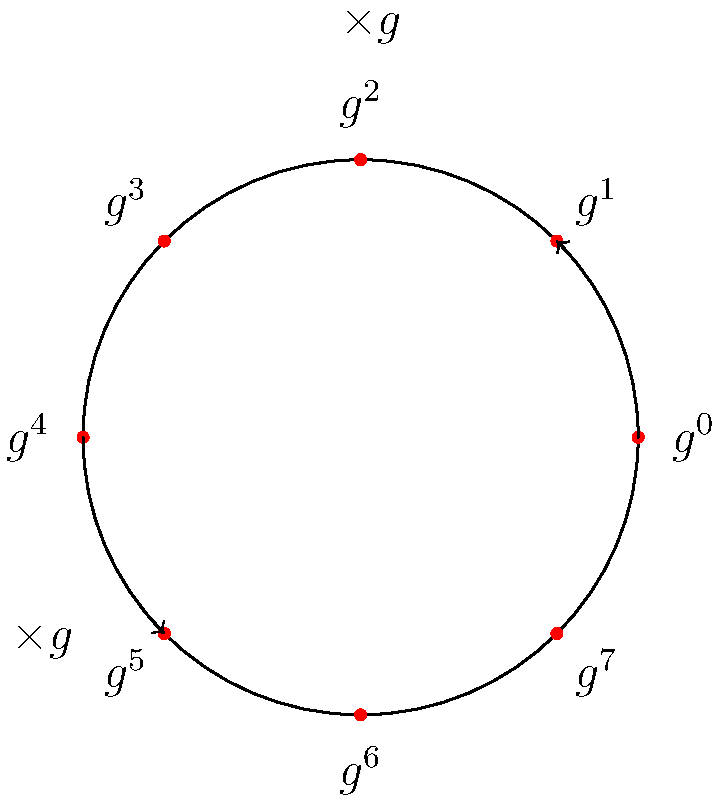In a secure communication protocol using a cyclic group of order 8, as shown in the diagram, Alice and Bob agree on a generator $g$. If Alice's private key is 3 and Bob's private key is 5, what is their shared secret key in terms of $g$? To solve this problem, we'll follow these steps:

1) In a Diffie-Hellman key exchange using cyclic groups:
   - Alice computes $g^a$ where $a$ is her private key
   - Bob computes $g^b$ where $b$ is his private key
   - They exchange these values
   - The shared secret is $g^{ab}$

2) Given:
   - Alice's private key $a = 3$
   - Bob's private key $b = 5$

3) Alice computes and sends: $g^3$
   Bob computes and sends: $g^5$

4) Alice then computes: $(g^5)^3 = g^{15}$
   Bob computes: $(g^3)^5 = g^{15}$

5) In a cyclic group of order 8, we know that $g^8 = g^0 = 1$
   Therefore, $g^{15} = g^{15 \bmod 8} = g^7$

Thus, the shared secret key is $g^7$.
Answer: $g^7$ 